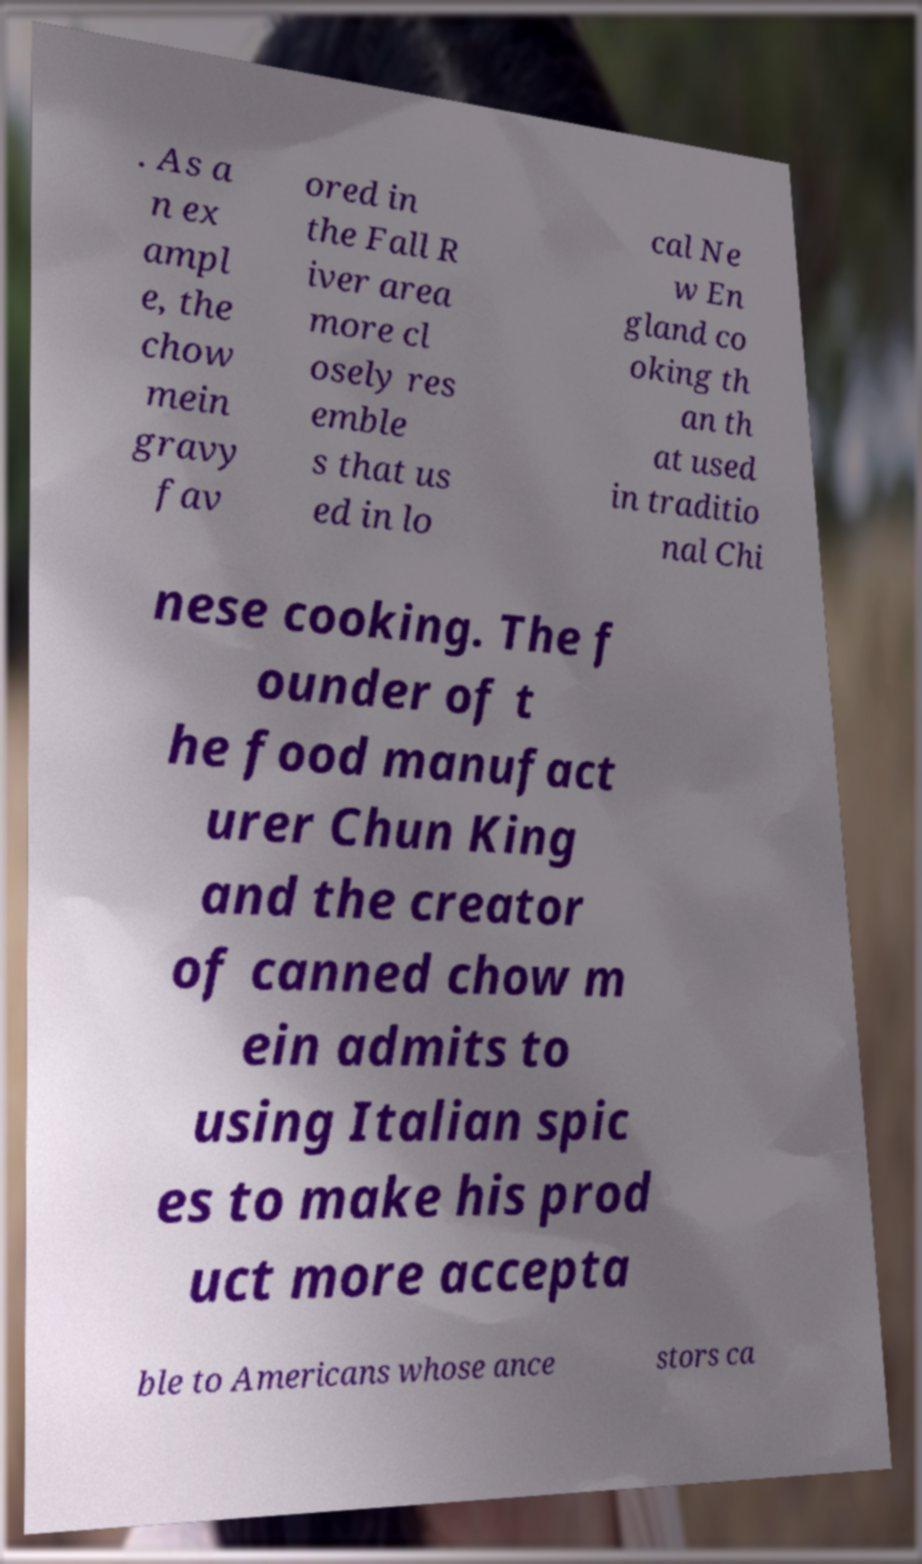Can you read and provide the text displayed in the image?This photo seems to have some interesting text. Can you extract and type it out for me? . As a n ex ampl e, the chow mein gravy fav ored in the Fall R iver area more cl osely res emble s that us ed in lo cal Ne w En gland co oking th an th at used in traditio nal Chi nese cooking. The f ounder of t he food manufact urer Chun King and the creator of canned chow m ein admits to using Italian spic es to make his prod uct more accepta ble to Americans whose ance stors ca 